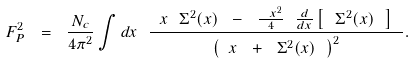<formula> <loc_0><loc_0><loc_500><loc_500>F _ { P } ^ { 2 } \ = \ \frac { N _ { c } } { 4 \pi ^ { 2 } } \int d x \ \frac { \ x \ \Sigma ^ { 2 } ( x ) \ - \ \frac { \ x ^ { 2 } } { 4 } \ \frac { d } { d x } \left [ \ \Sigma ^ { 2 } ( x ) \ \right ] \ } { \left ( \ x \ + \ \Sigma ^ { 2 } ( x ) \ \right ) ^ { 2 } } .</formula> 